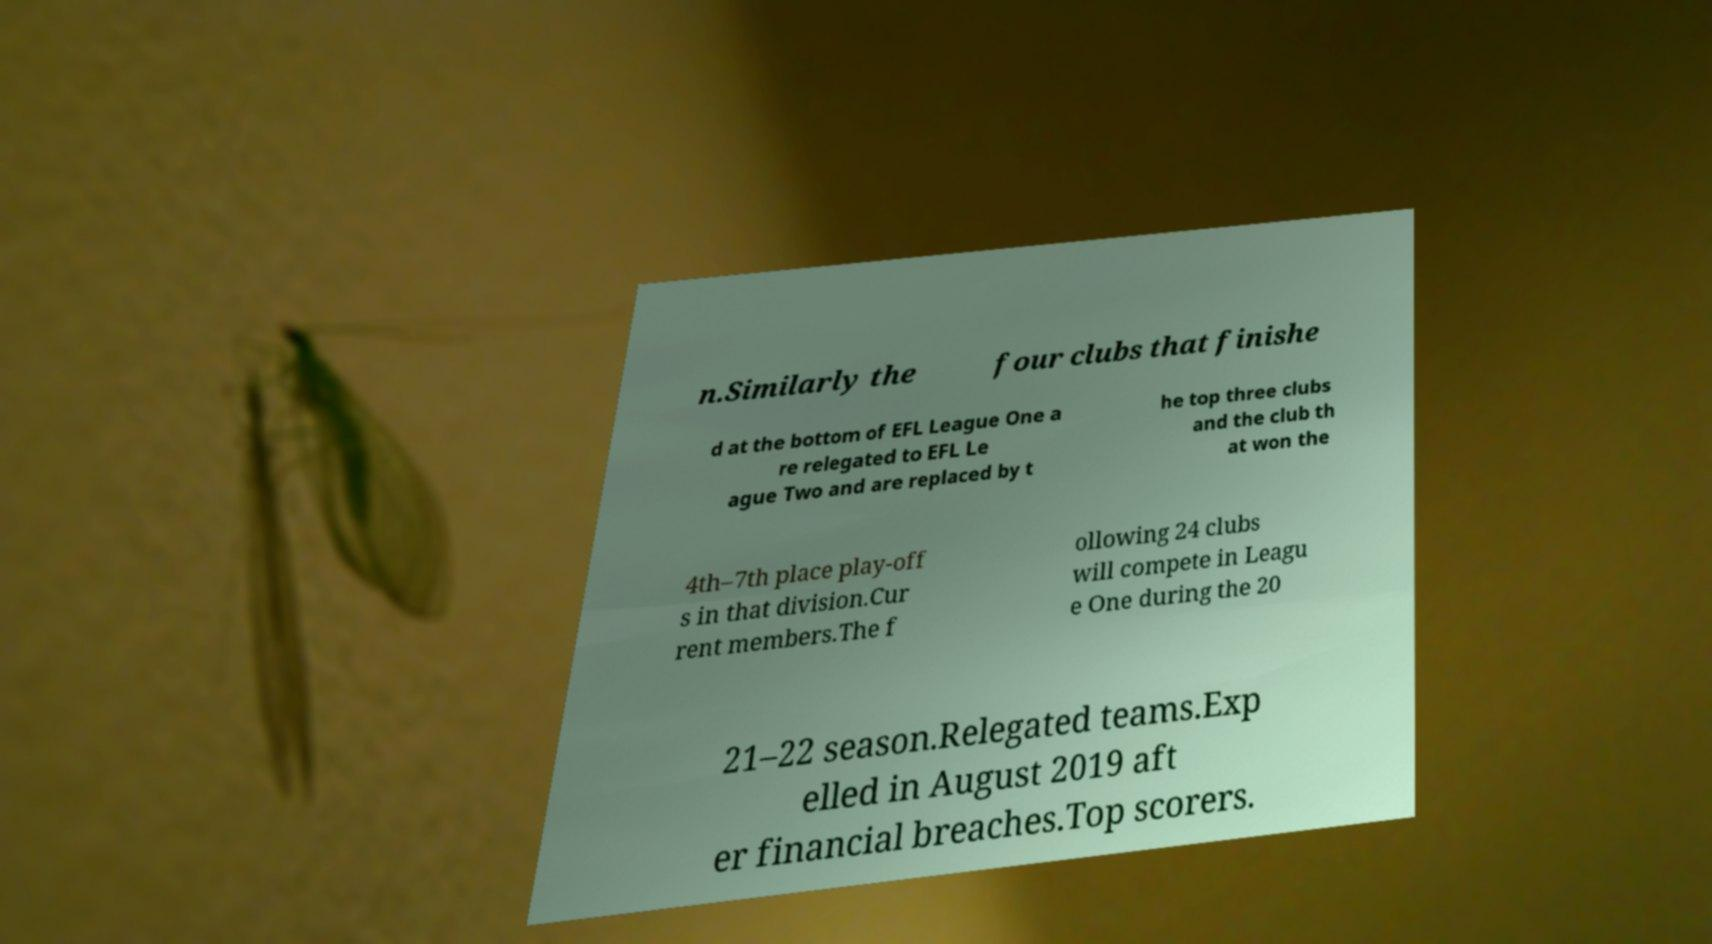I need the written content from this picture converted into text. Can you do that? n.Similarly the four clubs that finishe d at the bottom of EFL League One a re relegated to EFL Le ague Two and are replaced by t he top three clubs and the club th at won the 4th–7th place play-off s in that division.Cur rent members.The f ollowing 24 clubs will compete in Leagu e One during the 20 21–22 season.Relegated teams.Exp elled in August 2019 aft er financial breaches.Top scorers. 